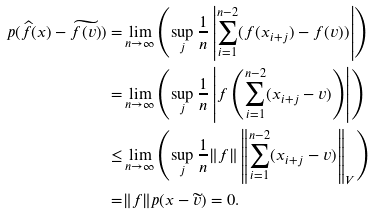Convert formula to latex. <formula><loc_0><loc_0><loc_500><loc_500>p ( \widehat { f } ( x ) - \widetilde { f ( v ) } ) = & \lim _ { n \rightarrow \infty } \left ( \sup _ { j } \frac { 1 } { n } \left | \sum _ { i = 1 } ^ { n - 2 } ( f ( x _ { i + j } ) - f ( v ) ) \right | \right ) \\ = & \lim _ { n \rightarrow \infty } \left ( \sup _ { j } \frac { 1 } { n } \left | f \left ( \sum _ { i = 1 } ^ { n - 2 } ( x _ { i + j } - v ) \right ) \right | \right ) \\ \leq & \lim _ { n \rightarrow \infty } \left ( \sup _ { j } \frac { 1 } { n } \| f \| \left \| \sum _ { i = 1 } ^ { n - 2 } ( x _ { i + j } - v ) \right \| _ { V } \right ) \\ = & \| f \| p ( x - \widetilde { v } ) = 0 .</formula> 